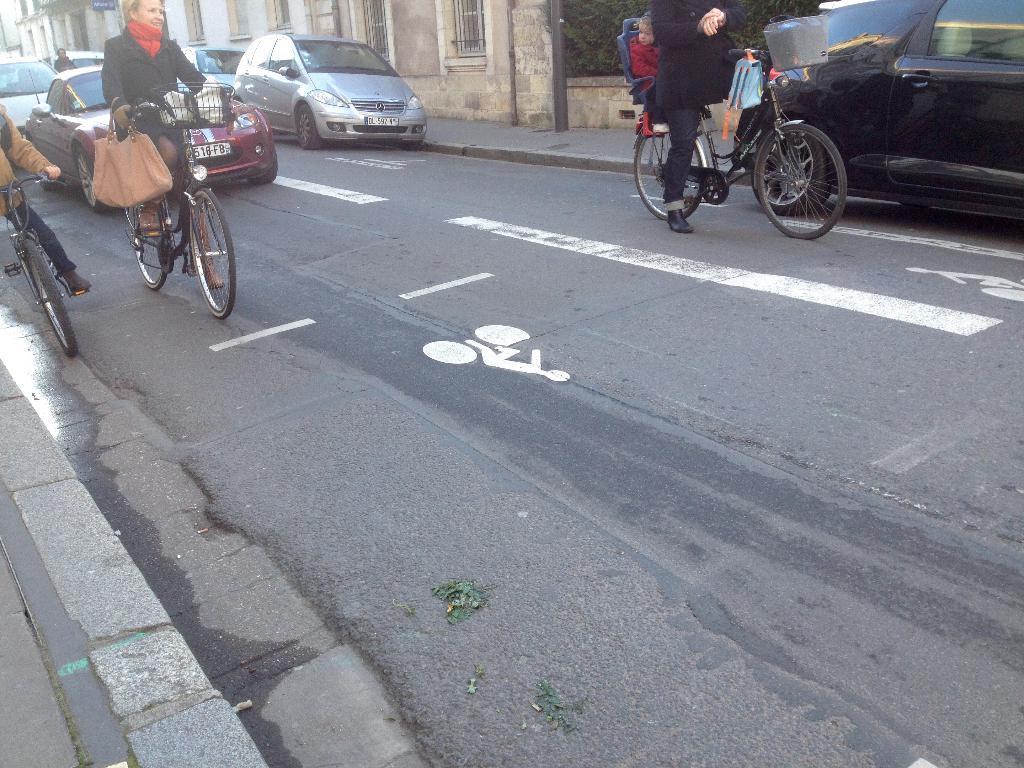How would you summarize this image in a sentence or two? In this picture we can see three persons carrying bags on bicycle and riding it on road and we can see cars on same road beside to it foot path, building with windows. 